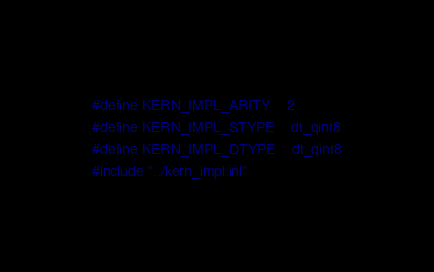Convert code to text. <code><loc_0><loc_0><loc_500><loc_500><_Cuda_>#define KERN_IMPL_ARITY    2
#define KERN_IMPL_STYPE    dt_qint8
#define KERN_IMPL_DTYPE    dt_qint8
#include "../kern_impl.inl"
</code> 